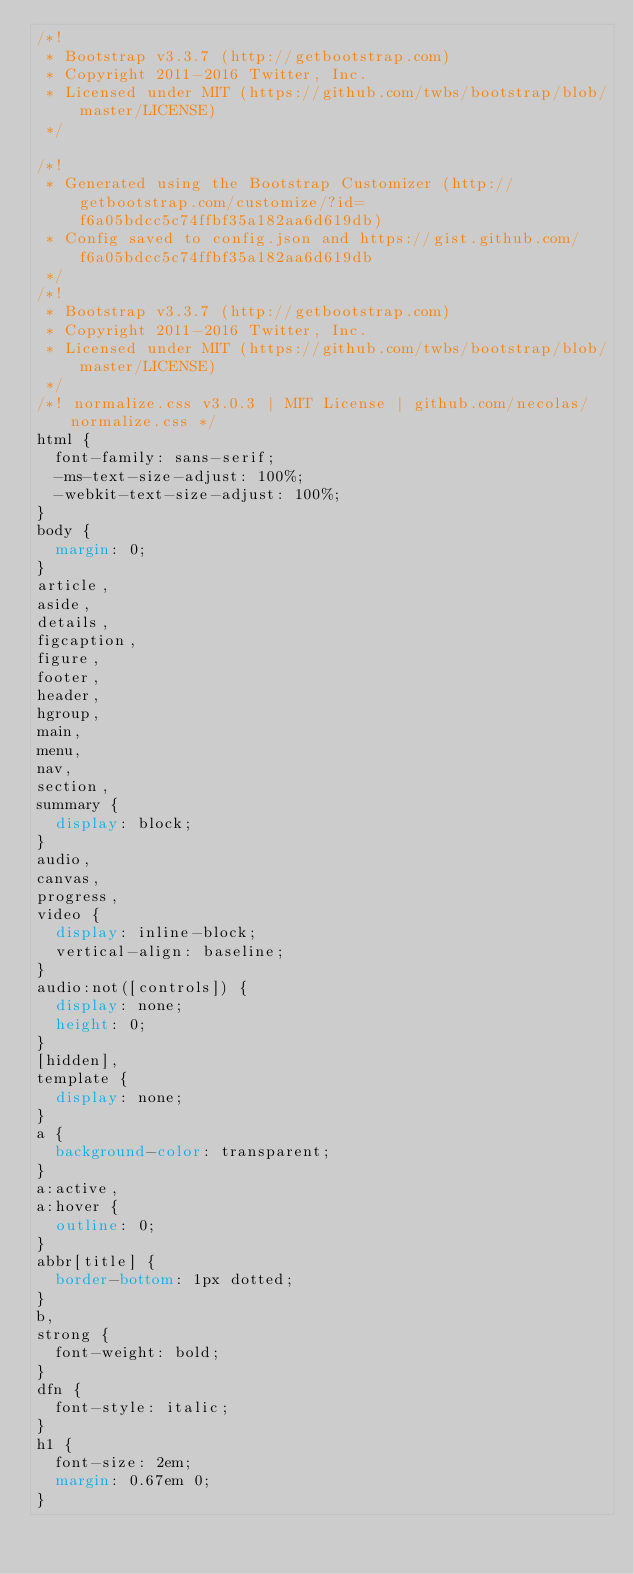<code> <loc_0><loc_0><loc_500><loc_500><_CSS_>/*!
 * Bootstrap v3.3.7 (http://getbootstrap.com)
 * Copyright 2011-2016 Twitter, Inc.
 * Licensed under MIT (https://github.com/twbs/bootstrap/blob/master/LICENSE)
 */

/*!
 * Generated using the Bootstrap Customizer (http://getbootstrap.com/customize/?id=f6a05bdcc5c74ffbf35a182aa6d619db)
 * Config saved to config.json and https://gist.github.com/f6a05bdcc5c74ffbf35a182aa6d619db
 */
/*!
 * Bootstrap v3.3.7 (http://getbootstrap.com)
 * Copyright 2011-2016 Twitter, Inc.
 * Licensed under MIT (https://github.com/twbs/bootstrap/blob/master/LICENSE)
 */
/*! normalize.css v3.0.3 | MIT License | github.com/necolas/normalize.css */
html {
  font-family: sans-serif;
  -ms-text-size-adjust: 100%;
  -webkit-text-size-adjust: 100%;
}
body {
  margin: 0;
}
article,
aside,
details,
figcaption,
figure,
footer,
header,
hgroup,
main,
menu,
nav,
section,
summary {
  display: block;
}
audio,
canvas,
progress,
video {
  display: inline-block;
  vertical-align: baseline;
}
audio:not([controls]) {
  display: none;
  height: 0;
}
[hidden],
template {
  display: none;
}
a {
  background-color: transparent;
}
a:active,
a:hover {
  outline: 0;
}
abbr[title] {
  border-bottom: 1px dotted;
}
b,
strong {
  font-weight: bold;
}
dfn {
  font-style: italic;
}
h1 {
  font-size: 2em;
  margin: 0.67em 0;
}</code> 